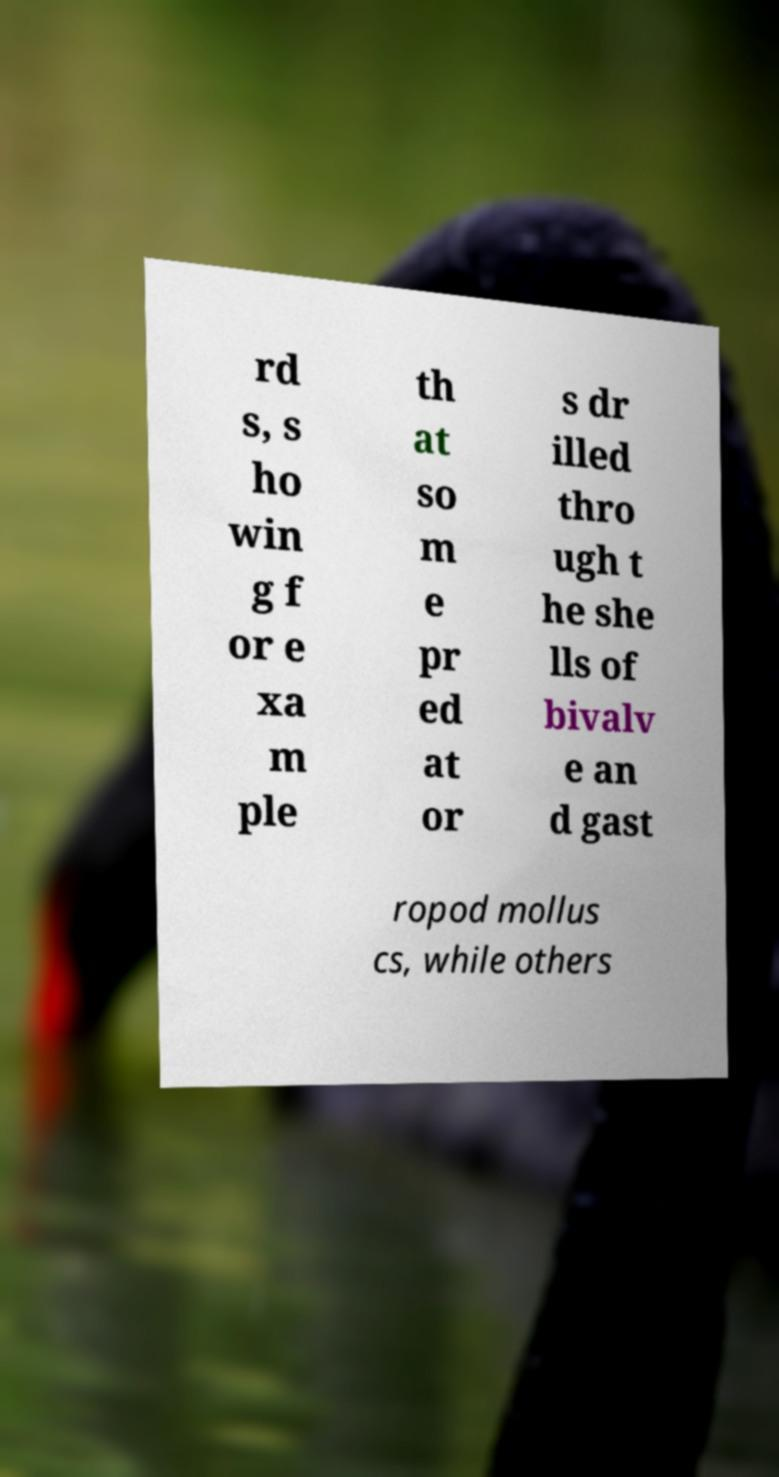Could you extract and type out the text from this image? rd s, s ho win g f or e xa m ple th at so m e pr ed at or s dr illed thro ugh t he she lls of bivalv e an d gast ropod mollus cs, while others 